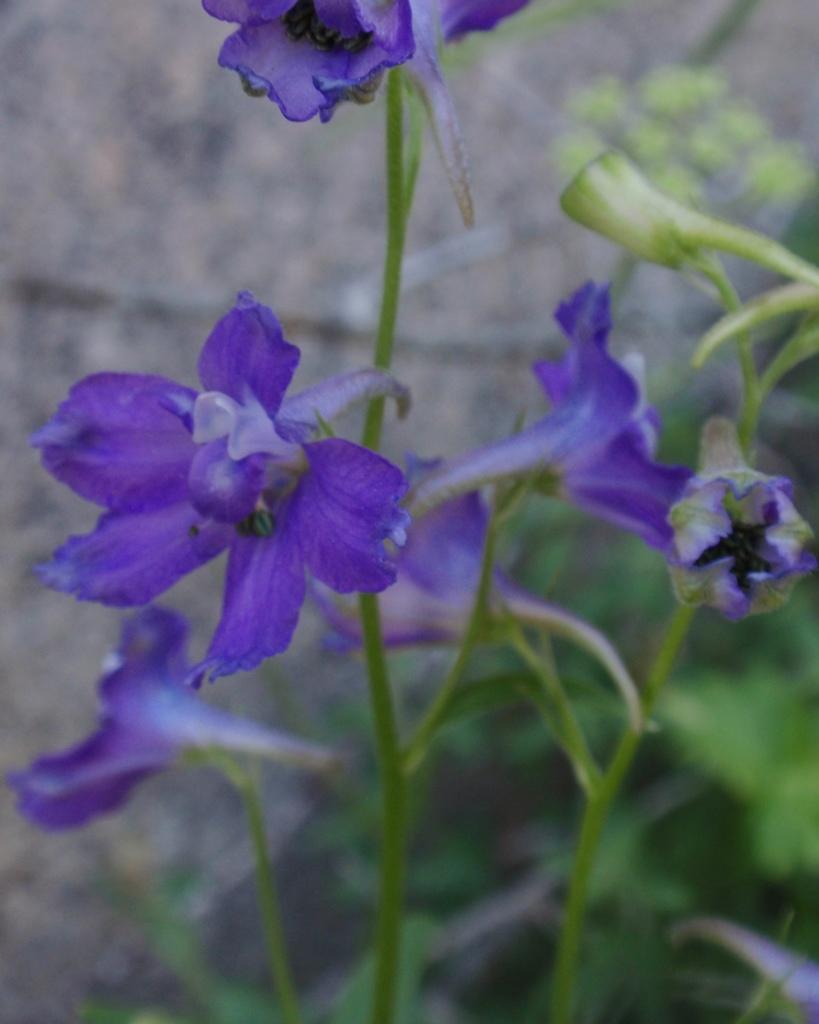In one or two sentences, can you explain what this image depicts? In this image, I can see a plant with flowers. There is a blurred background. 